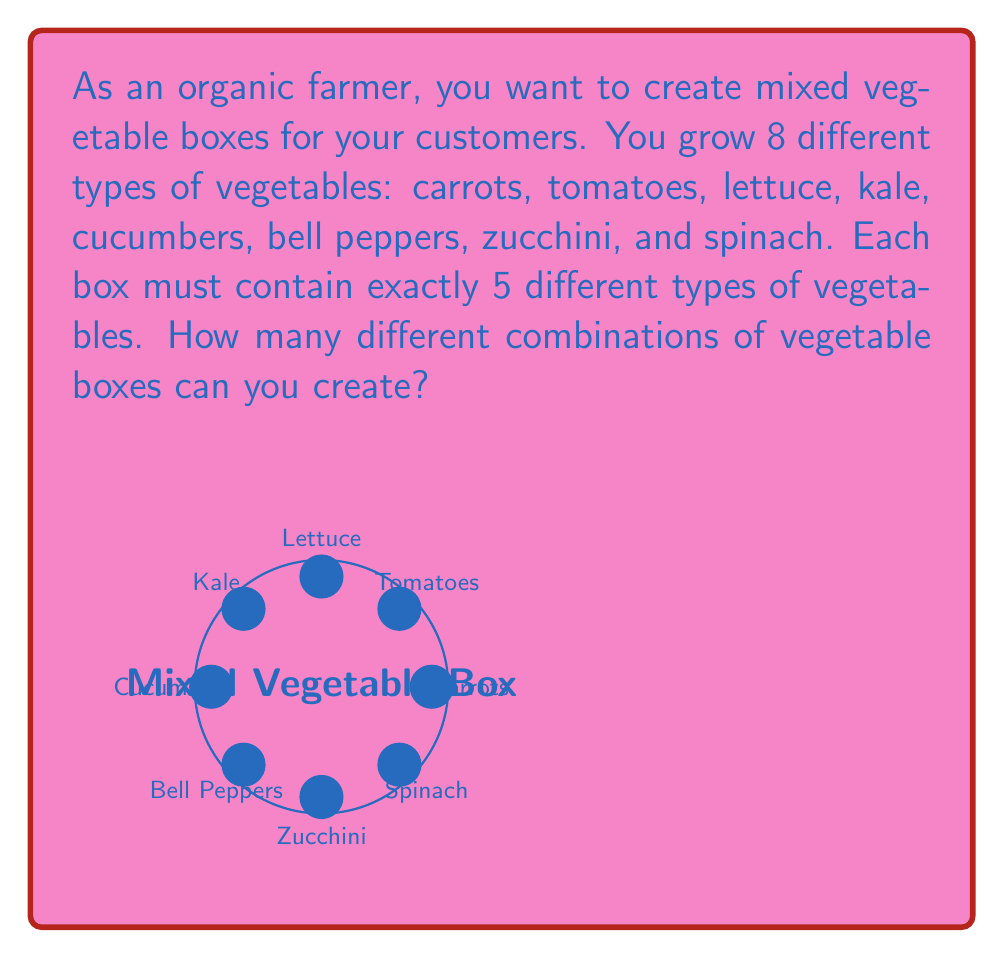Teach me how to tackle this problem. To solve this problem, we need to use the combination formula. We are selecting 5 vegetables out of 8 without repetition, and the order doesn't matter (since we're just creating a box, not arranging them).

The formula for combinations is:

$$C(n,r) = \frac{n!}{r!(n-r)!}$$

Where:
$n$ is the total number of items to choose from (in this case, 8 vegetables)
$r$ is the number of items being chosen (in this case, 5 vegetables)

Let's substitute these values:

$$C(8,5) = \frac{8!}{5!(8-5)!} = \frac{8!}{5!3!}$$

Now, let's calculate this step-by-step:

1) First, expand this:
   $$\frac{8 * 7 * 6 * 5!}{5! * 3 * 2 * 1}$$

2) The 5! cancels out in the numerator and denominator:
   $$\frac{8 * 7 * 6}{3 * 2 * 1}$$

3) Multiply the numerator and denominator:
   $$\frac{336}{6}$$

4) Divide:
   $$56$$

Therefore, you can create 56 different combinations of vegetable boxes.
Answer: 56 